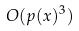Convert formula to latex. <formula><loc_0><loc_0><loc_500><loc_500>O ( p ( x ) ^ { 3 } )</formula> 